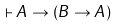<formula> <loc_0><loc_0><loc_500><loc_500>\vdash A \rightarrow ( B \rightarrow A )</formula> 